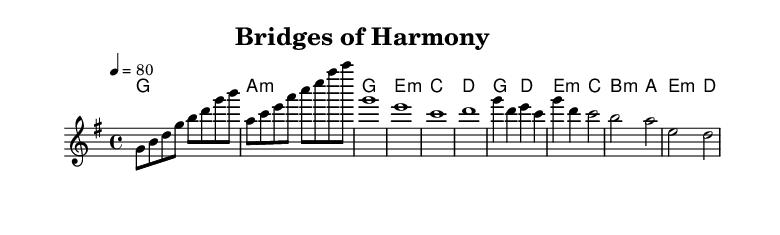What is the key signature of this music? The key signature is G major, which has one sharp (F#). This can be identified from the key signature marked at the beginning of the score.
Answer: G major What is the time signature of the piece? The time signature is 4/4. This means there are four beats in each measure, with the quarter note getting one beat. It's indicated at the start of the score.
Answer: 4/4 What is the tempo marking for the music? The tempo marking is 80 beats per minute. This is clearly stated above the staff, indicating how fast the music should be played.
Answer: 80 How many measures are in the chorus section? The chorus consists of 2 measures, as indicated by the notation in that part of the score, specifically the sequence where the melody and chords align.
Answer: 2 What chord follows the melody G in the chorus? The chord that follows the melody G is D. In the score, you can see that in the chorus section, after the G melody, the D chord is placed directly below it.
Answer: D What is the final chord in the bridge? The final chord in the bridge is D minor. This can be found by looking at the bridge section of the music where the harmonies are laid out in chord form, and it ends on D.
Answer: D minor How does the theme of the song relate to its harmonic progression? The theme of diplomacy and cultural understanding is supported by its harmonious chord progressions that emphasize resolution and connection, reflecting the idea of bridging gaps in understanding. This is seen throughout the song in how each part transitions smoothly into the next, creating a cohesive whole.
Answer: Cohesive whole 